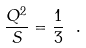<formula> <loc_0><loc_0><loc_500><loc_500>\frac { Q ^ { 2 } } { S } = \frac { 1 } { 3 } \ .</formula> 